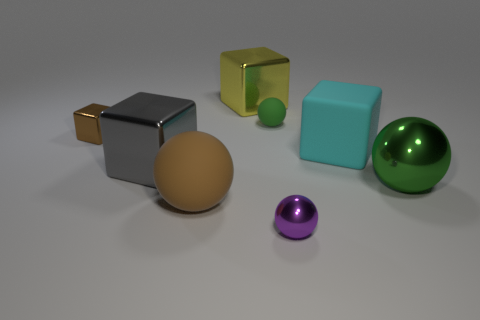Do the green thing to the right of the green matte sphere and the green sphere behind the tiny brown metallic cube have the same material?
Your answer should be compact. No. Are there an equal number of large cyan rubber cubes in front of the gray shiny block and green shiny objects that are in front of the small purple object?
Give a very brief answer. Yes. What number of tiny matte spheres are the same color as the large metal ball?
Provide a succinct answer. 1. There is a large ball that is the same color as the small cube; what material is it?
Your answer should be compact. Rubber. What number of metallic objects are tiny green things or blocks?
Keep it short and to the point. 3. Is the shape of the green object in front of the small brown object the same as the metal thing behind the tiny rubber thing?
Your answer should be compact. No. There is a brown ball; what number of small purple metallic things are to the left of it?
Provide a short and direct response. 0. Are there any big cubes made of the same material as the big brown sphere?
Keep it short and to the point. Yes. What is the material of the green thing that is the same size as the yellow block?
Offer a terse response. Metal. Is the material of the big cyan object the same as the brown cube?
Your answer should be compact. No. 